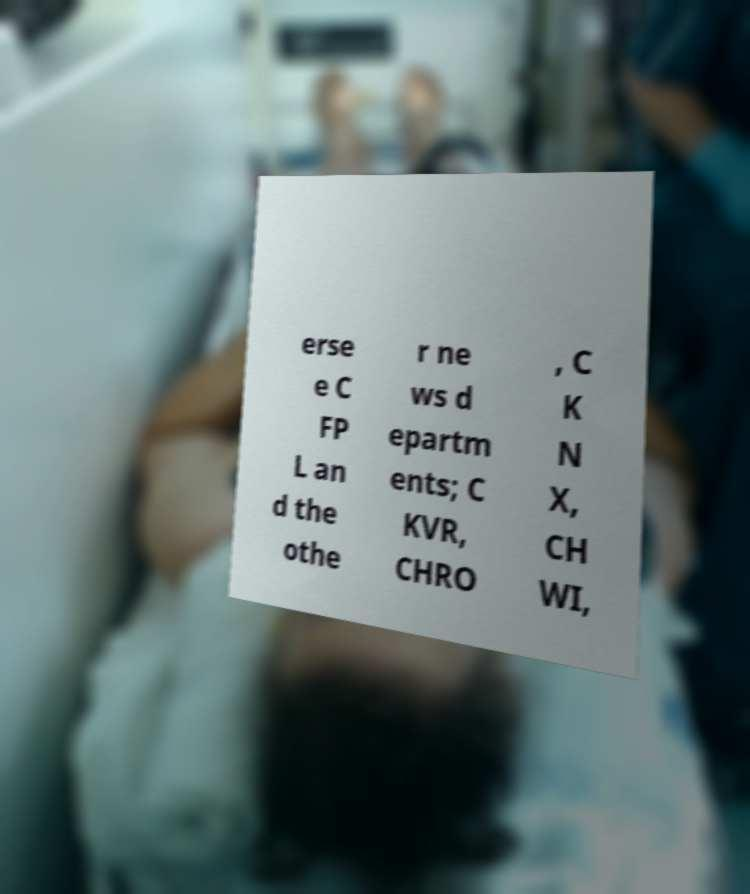Could you extract and type out the text from this image? erse e C FP L an d the othe r ne ws d epartm ents; C KVR, CHRO , C K N X, CH WI, 